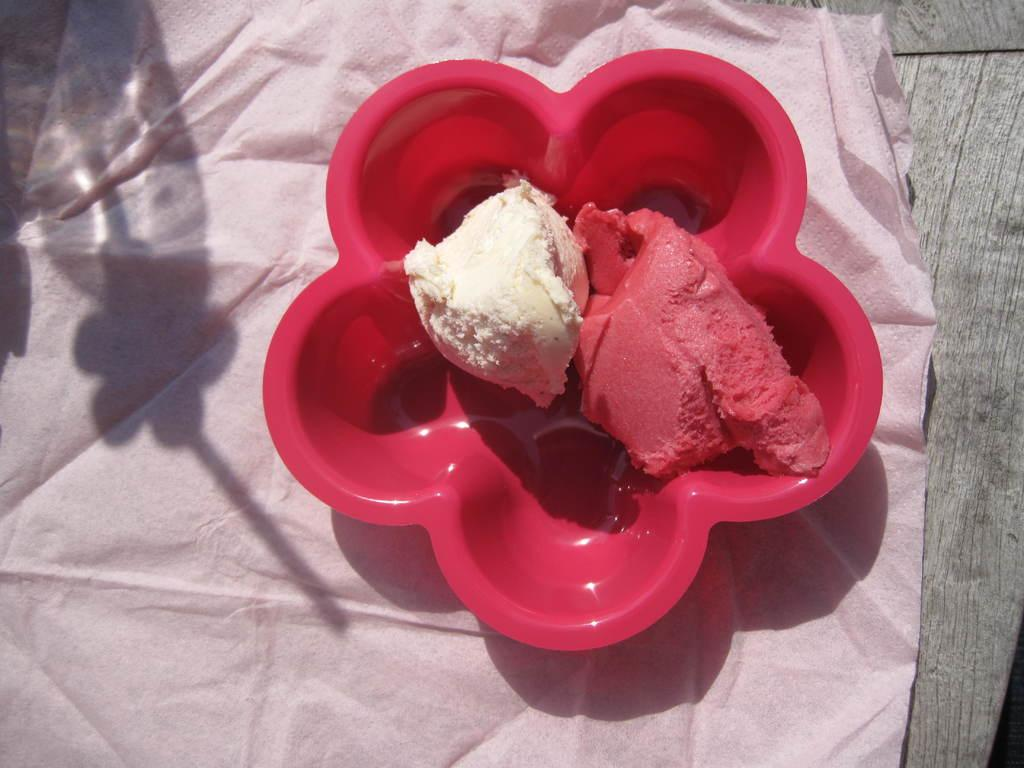What color is the ice-cream in the image? The ice-cream is white and red in color. What is the ice-cream placed on in the image? The ice-cream is placed on a red color plate. What is the plate resting on in the image? The plate is on a pink tissue. Where is the pink tissue located in the image? The pink tissue is on a table. How many women are involved in the trade of ice-cream in the image? There are no women or trade-related activities depicted in the image; it simply shows a plate of ice-cream on a pink tissue. 